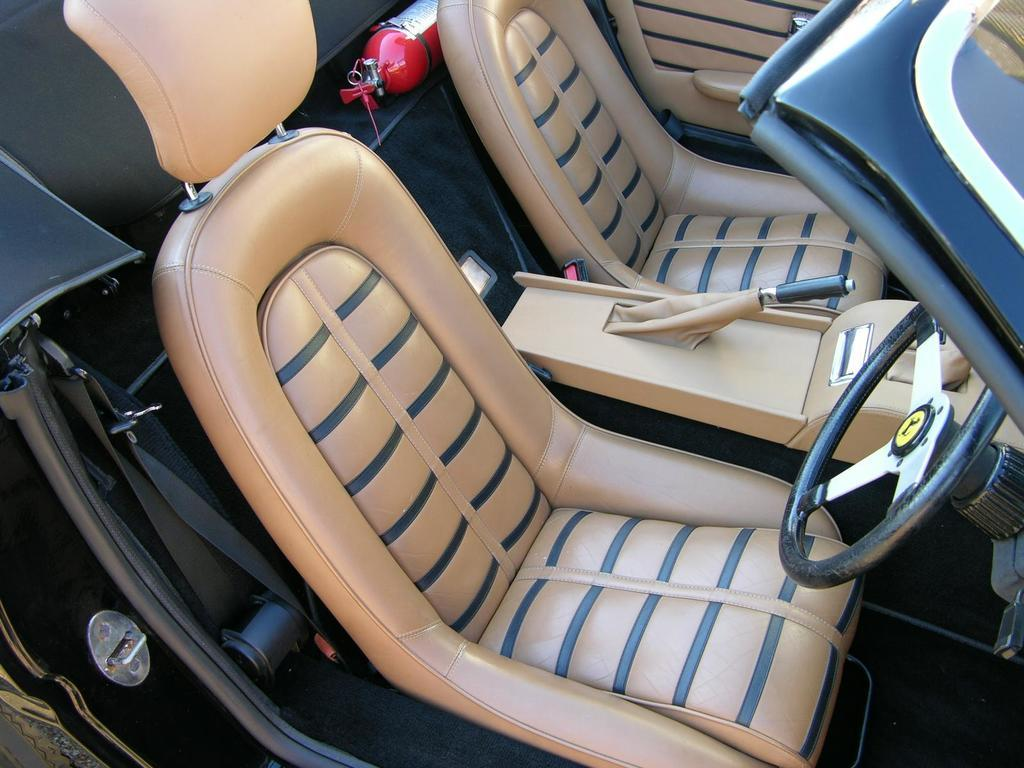What type of space is shown in the image? The image shows the interior of a car. How many seats are in the car? There are two seats in the car. What is used to control the direction of the car? A steering wheel is present in the car. What is used to prevent the car from rolling when parked? A hand break is visible in the car. Can you describe any other objects present in the car? There are other objects in the car, but their specific details are not mentioned in the provided facts. What type of coast can be seen from the car window in the image? There is no coast visible in the image, as it shows the interior of a car. Is the car's grandfather having trouble starting the engine in the image? There is no mention of a grandfather or any trouble starting the engine in the provided facts. 